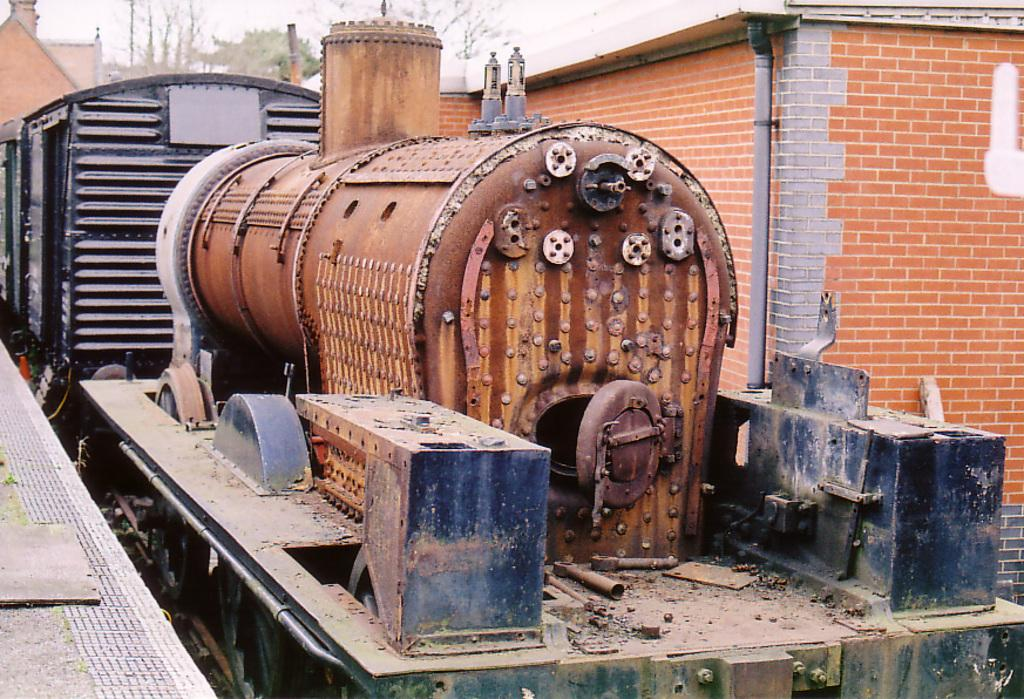What is the main subject of the picture? The main subject of the picture is a train. What can be seen in the background of the picture? There are buildings, a pipe attached to a brick wall, trees, and other unspecified objects in the background of the picture. What is the price of the ant crawling on the train in the image? There is no ant present in the image, so it is not possible to determine its price. 